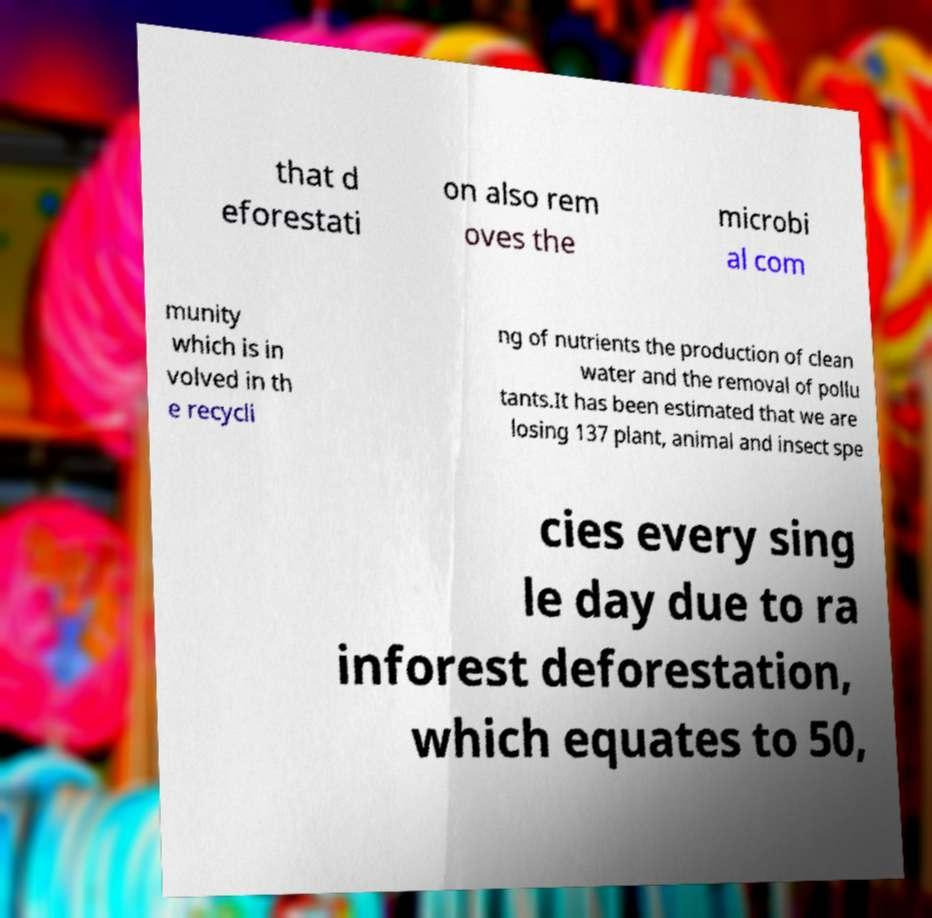I need the written content from this picture converted into text. Can you do that? that d eforestati on also rem oves the microbi al com munity which is in volved in th e recycli ng of nutrients the production of clean water and the removal of pollu tants.It has been estimated that we are losing 137 plant, animal and insect spe cies every sing le day due to ra inforest deforestation, which equates to 50, 